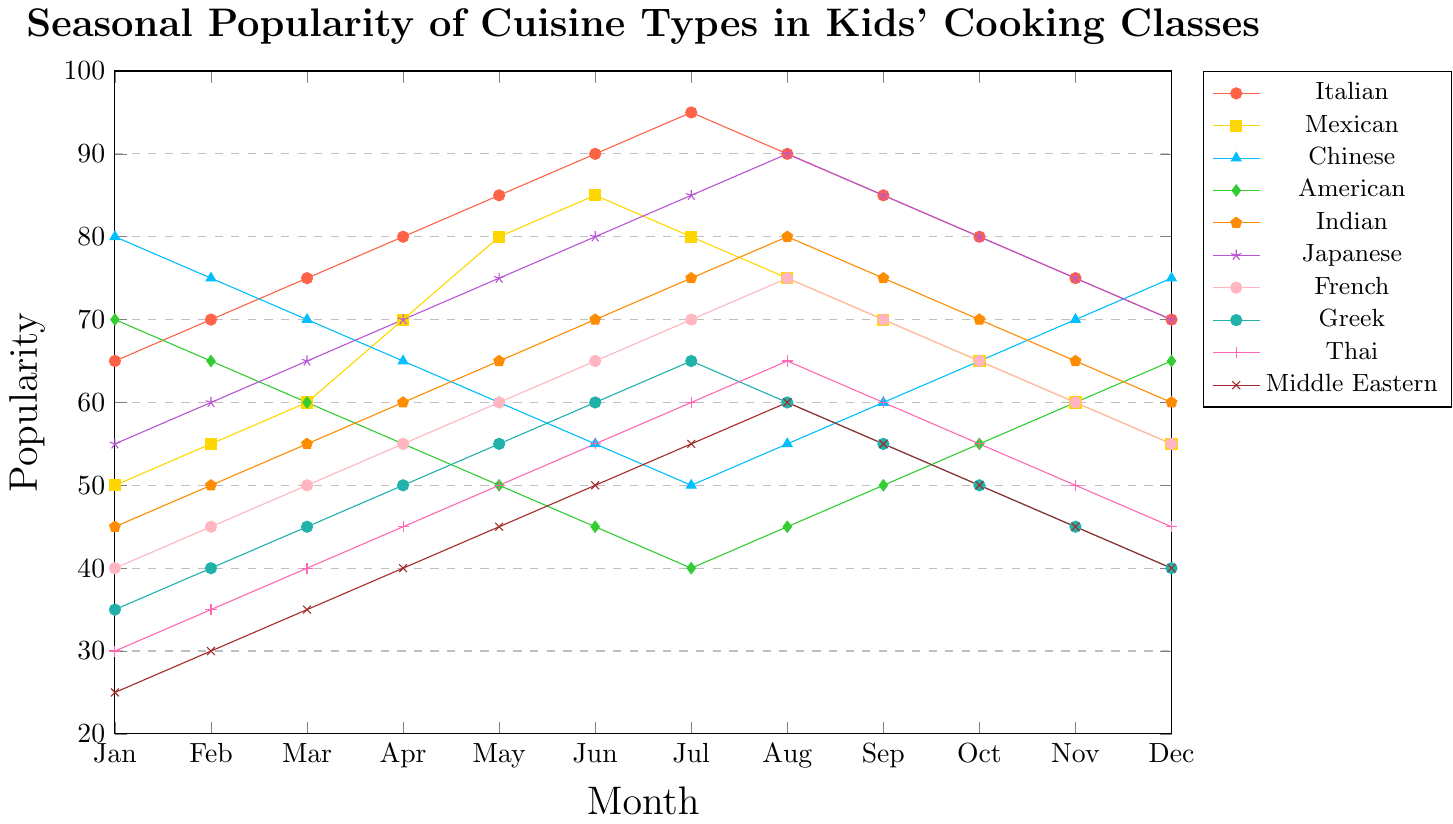Which cuisine type has the highest popularity in January? From the line chart, the highest point in January is for Chinese cuisine, which is indicated at 80.
Answer: Chinese How does the popularity of American cuisine change from January to December? The line for American cuisine starts at a high point of 70 in January and decreases steadily to 40 in July. It then returns to 65 by December. The popularity decreases from January to July and increases from July to December.
Answer: Decreases then increases What is the difference in popularity between Italian and Japanese cuisines in July? The popularity of Italian cuisine in July is 95, and the popularity of Japanese cuisine is 85. The difference is 95 - 85.
Answer: 10 Which cuisine type shows the least variation in popularity throughout the year? To determine the least variation, we need to look at the range (difference between the maximum and minimum values). The smallest range is for Chinese cuisine, varying from 50 to 80.
Answer: Chinese What is the average popularity of Indian cuisine over the year? Add the monthly values for Indian cuisine (45, 50, 55, 60, 65, 70, 75, 80, 75, 70, 65, 60) and divide by 12. The sum is 770, so the average is 770/12.
Answer: 64.17 During which month is Mexican cuisine most popular? Referring to the line representing Mexican cuisine, the highest popularity point is in June where it reaches 85.
Answer: June Are there any months where two cuisine types have equal popularity? By examining the graph, we can see that in January, both Japanese and Mexican cuisines have a popularity of 55.
Answer: Yes How much more popular is Italian cuisine compared to Middle Eastern cuisine in December? In December, Italian cuisine has a popularity of 70 and Middle Eastern cuisine has 40. The difference is 70 - 40.
Answer: 30 Which cuisine type has a consistent increase in popularity from January to July? The cuisines with lines increasing steadily from January to July are Italian, Indian, Japanese, and French. They all increase consistently.
Answer: Italian, Indian, Japanese, French By how much does the popularity of Greek cuisine drop from August to December? Greek cuisine has a popularity of 60 in August, and it drops to 40 in December. The decrease is 60 - 40.
Answer: 20 